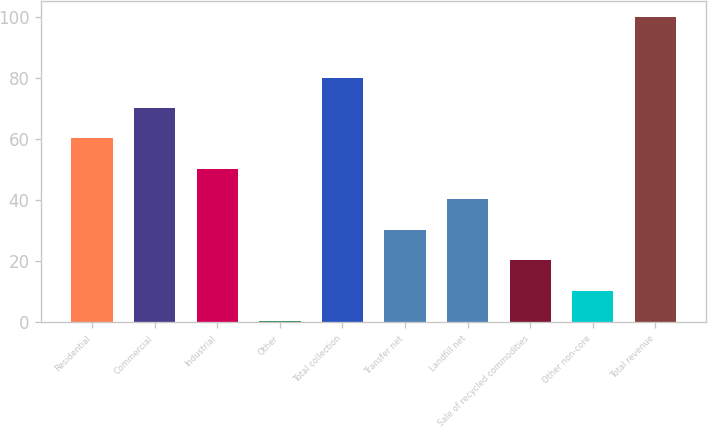Convert chart to OTSL. <chart><loc_0><loc_0><loc_500><loc_500><bar_chart><fcel>Residential<fcel>Commercial<fcel>Industrial<fcel>Other<fcel>Total collection<fcel>Transfer net<fcel>Landfill net<fcel>Sale of recycled commodities<fcel>Other non-core<fcel>Total revenue<nl><fcel>60.16<fcel>70.12<fcel>50.2<fcel>0.4<fcel>80.08<fcel>30.28<fcel>40.24<fcel>20.32<fcel>10.36<fcel>100<nl></chart> 